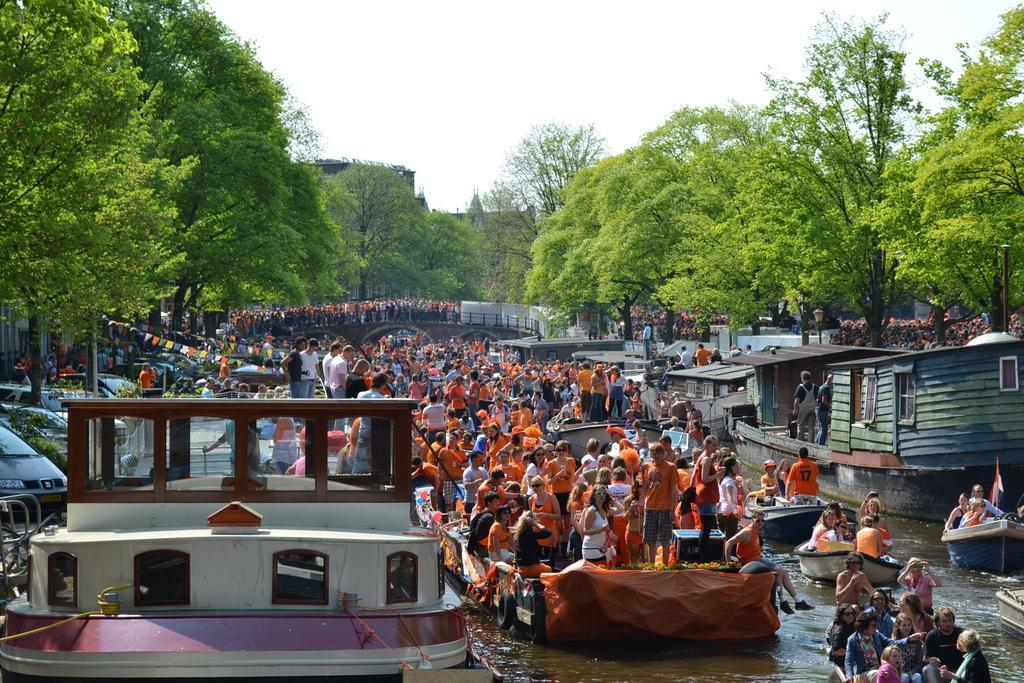How would you summarize this image in a sentence or two? In this image we can see a group of people on the boats which are in a water body. We can also see a group of people standing on a bridge, some vehicles parked aside, poles, flags, a group of trees, some buildings and the sky. 